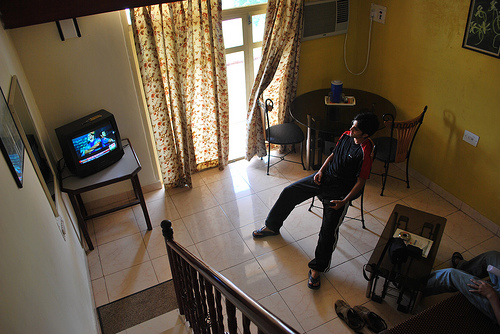What activity is the standing person in the image engaged in? The standing person appears to be engaged in watching television, likely enjoying a program or perhaps playing a video game given their focused posture. 